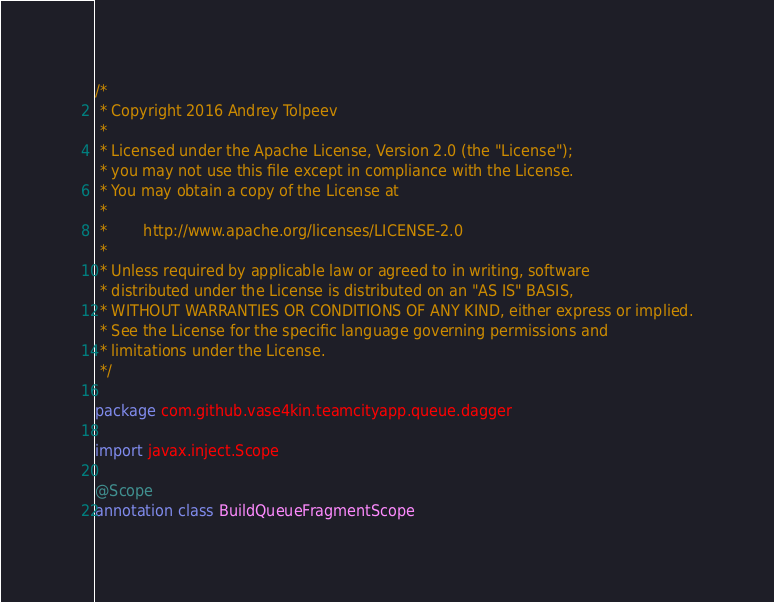Convert code to text. <code><loc_0><loc_0><loc_500><loc_500><_Kotlin_>/*
 * Copyright 2016 Andrey Tolpeev
 *
 * Licensed under the Apache License, Version 2.0 (the "License");
 * you may not use this file except in compliance with the License.
 * You may obtain a copy of the License at
 *
 *        http://www.apache.org/licenses/LICENSE-2.0
 *
 * Unless required by applicable law or agreed to in writing, software
 * distributed under the License is distributed on an "AS IS" BASIS,
 * WITHOUT WARRANTIES OR CONDITIONS OF ANY KIND, either express or implied.
 * See the License for the specific language governing permissions and
 * limitations under the License.
 */

package com.github.vase4kin.teamcityapp.queue.dagger

import javax.inject.Scope

@Scope
annotation class BuildQueueFragmentScope
</code> 